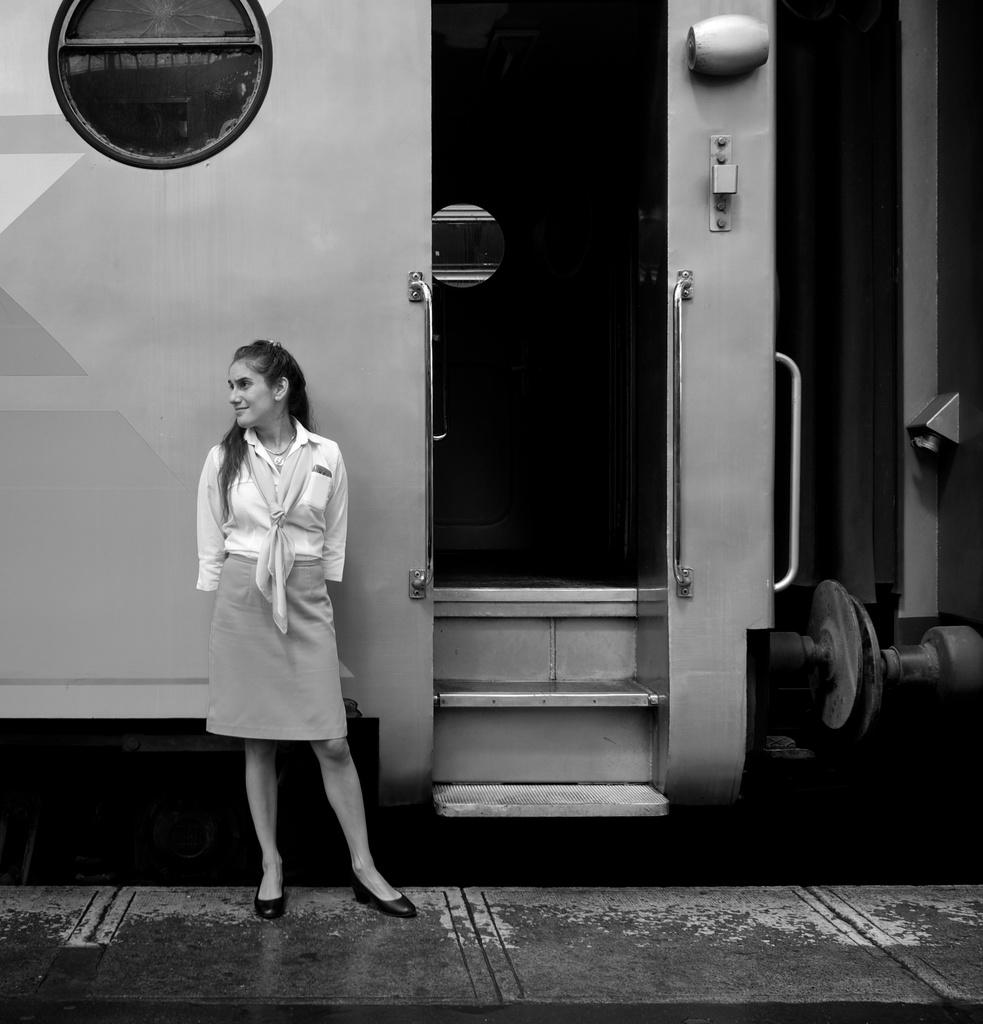What is the color scheme of the image? The image is black and white. Who is present in the image? There is a woman in the image. What is the woman doing in the image? The woman is standing on a platform and smiling. Which direction is the woman looking in the image? The woman is looking to the left side. What can be seen behind the woman in the image? There is a train behind the woman. How many kittens are hiding in the cellar in the image? There are no kittens or cellars present in the image. What memories does the woman have while standing on the platform? The image does not provide information about the woman's memories, so we cannot determine what she might be thinking or remembering. 